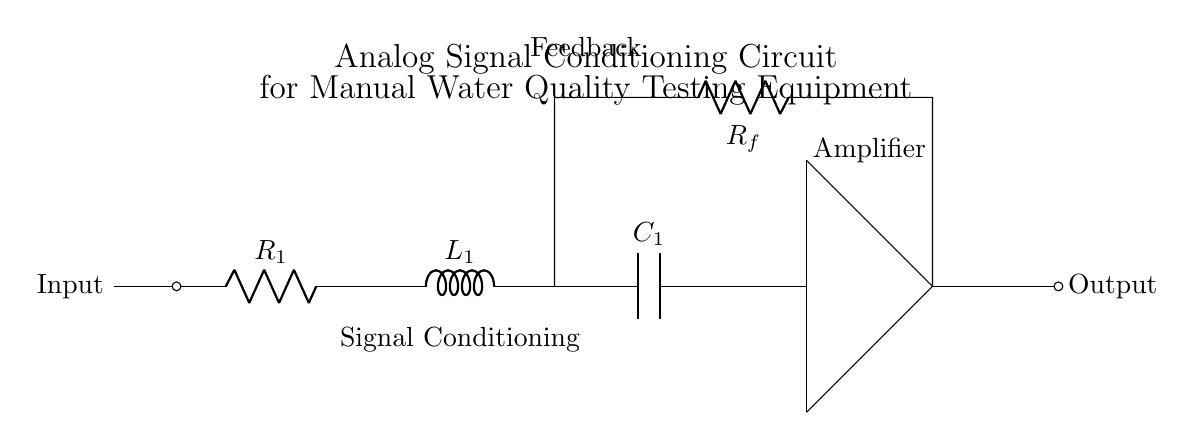What does R1 represent in this circuit? R1 is the first resistor in the series and provides resistance to the incoming signal.
Answer: Resistor What is the purpose of L1 in this circuit? L1 is an inductor that stores energy in a magnetic field when current passes through it, helping to filter the signal.
Answer: Energy storage What type of component is C1? C1 is a capacitor that stores electrical energy and helps smooth out the signal by filtering high-frequency noise.
Answer: Capacitor What is the role of Rf in this circuit? Rf is a feedback resistor that facilitates feedback from the output back to the circuit to stabilize or modify the gain of the amplifier.
Answer: Feedback resistor How many branches does the signal take? The signal goes through a series connection of R1, L1, and C1, followed by the amplifier, resulting in one main branch.
Answer: One What is the main function of the circuit? The main function is to condition the analog signal for better accuracy and integrity in manually testing water quality parameters.
Answer: Signal conditioning Why is it important to use both inductors and capacitors in this circuit? Inductors and capacitors serve complementary functions in filtering signals; inductors smoothen current changes while capacitors manage voltage variations, enhancing signal quality.
Answer: Filtering 